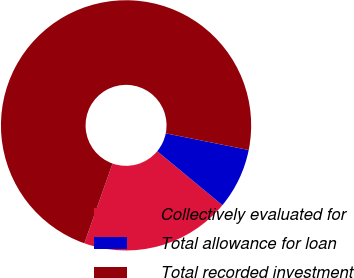<chart> <loc_0><loc_0><loc_500><loc_500><pie_chart><fcel>Collectively evaluated for<fcel>Total allowance for loan<fcel>Total recorded investment<nl><fcel>19.39%<fcel>7.86%<fcel>72.75%<nl></chart> 